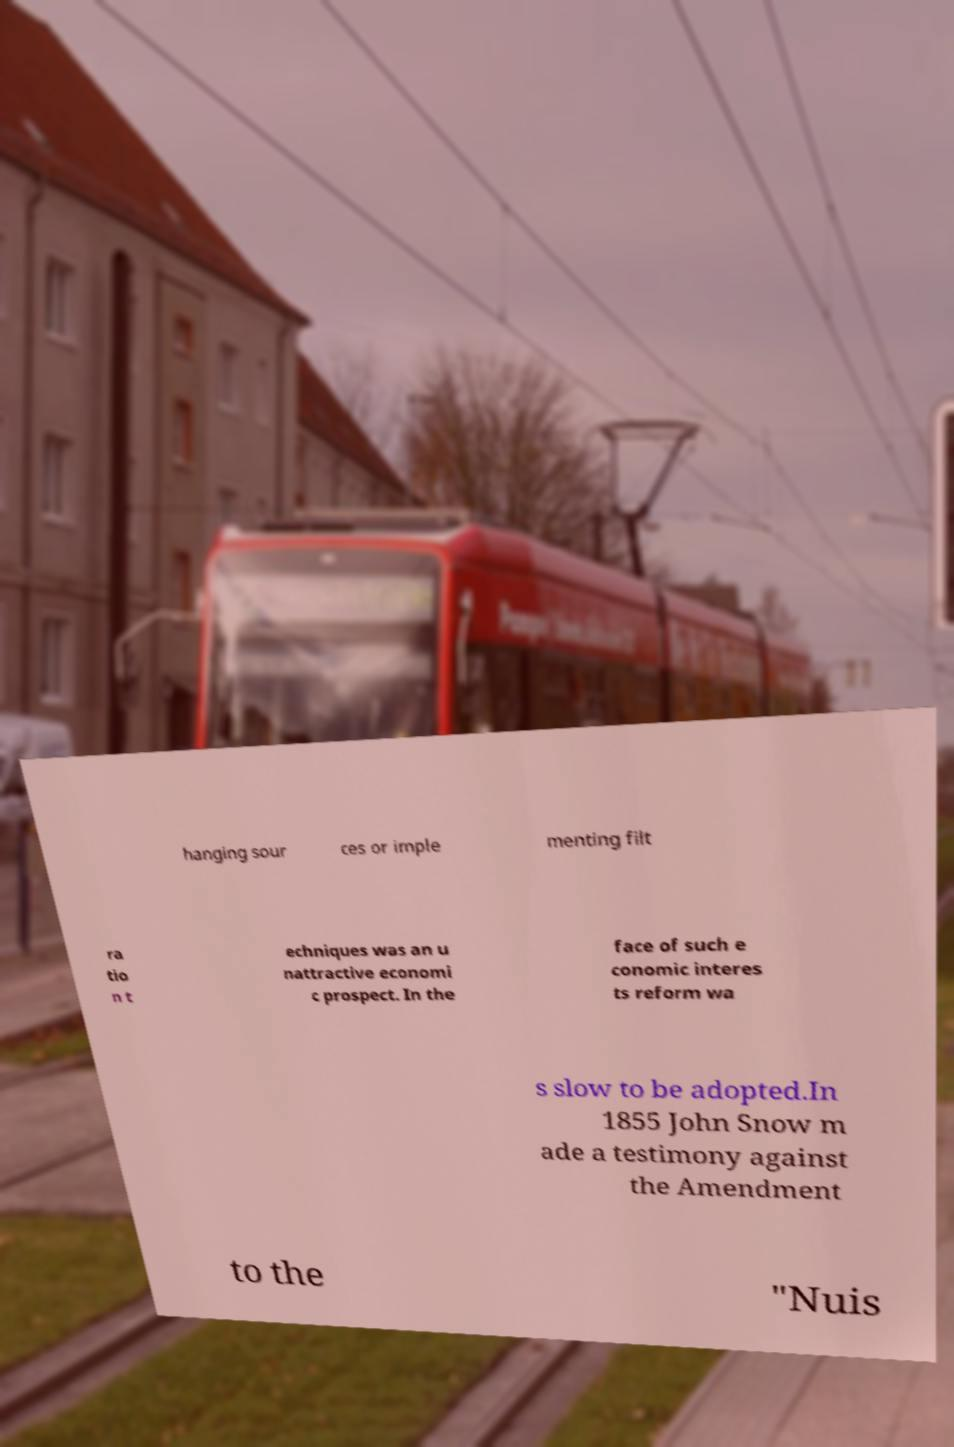Please identify and transcribe the text found in this image. hanging sour ces or imple menting filt ra tio n t echniques was an u nattractive economi c prospect. In the face of such e conomic interes ts reform wa s slow to be adopted.In 1855 John Snow m ade a testimony against the Amendment to the "Nuis 